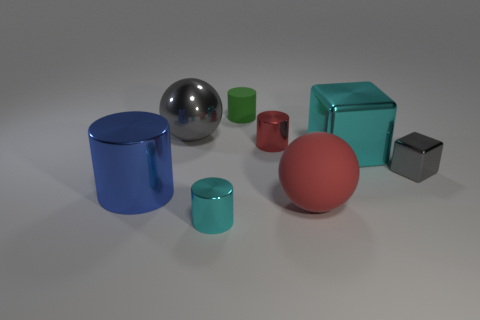Are there more large metallic objects that are to the right of the gray cube than big blue metal things that are in front of the big metallic cylinder?
Your answer should be very brief. No. How many metallic objects are blue cylinders or small red cylinders?
Make the answer very short. 2. What shape is the tiny object that is the same color as the large metallic block?
Provide a succinct answer. Cylinder. What is the big object that is in front of the big blue cylinder made of?
Ensure brevity in your answer.  Rubber. How many objects are large cyan things or tiny metal objects that are to the left of the red rubber thing?
Make the answer very short. 3. There is a gray object that is the same size as the red metallic cylinder; what is its shape?
Your answer should be compact. Cube. What number of small things are the same color as the big cylinder?
Keep it short and to the point. 0. Is the material of the cyan thing that is on the right side of the red matte sphere the same as the large blue cylinder?
Keep it short and to the point. Yes. The tiny green object is what shape?
Offer a terse response. Cylinder. How many cyan things are either big shiny balls or small cubes?
Your answer should be very brief. 0. 